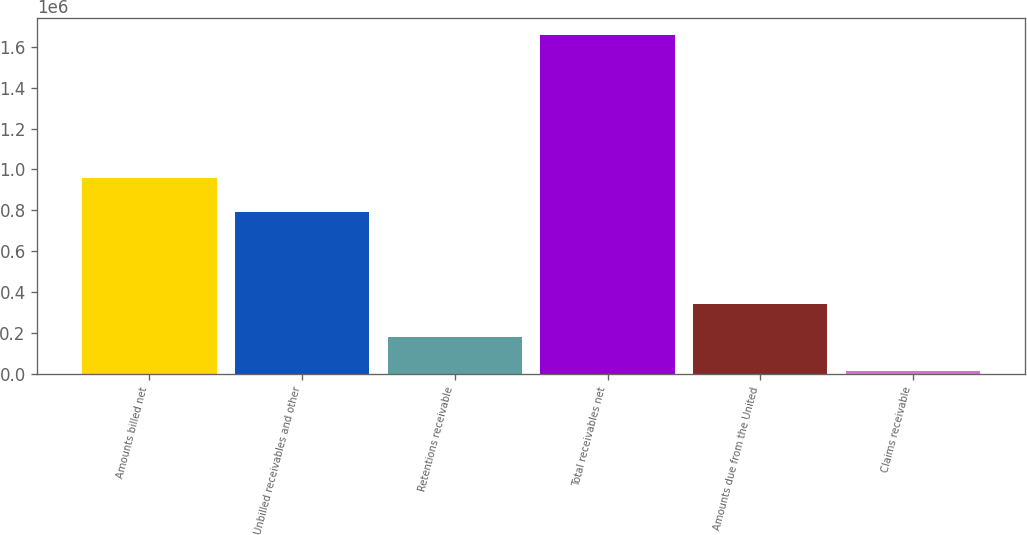Convert chart to OTSL. <chart><loc_0><loc_0><loc_500><loc_500><bar_chart><fcel>Amounts billed net<fcel>Unbilled receivables and other<fcel>Retentions receivable<fcel>Total receivables net<fcel>Amounts due from the United<fcel>Claims receivable<nl><fcel>958482<fcel>793918<fcel>178765<fcel>1.65984e+06<fcel>343330<fcel>14201<nl></chart> 